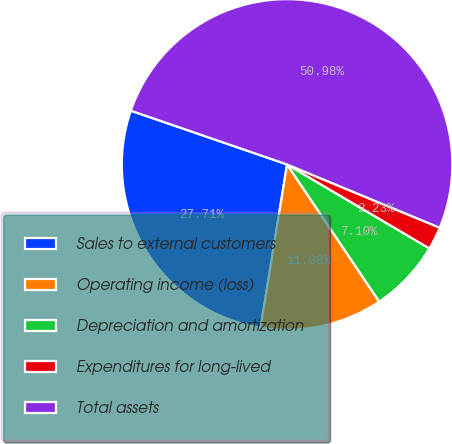Convert chart to OTSL. <chart><loc_0><loc_0><loc_500><loc_500><pie_chart><fcel>Sales to external customers<fcel>Operating income (loss)<fcel>Depreciation and amortization<fcel>Expenditures for long-lived<fcel>Total assets<nl><fcel>27.71%<fcel>11.98%<fcel>7.1%<fcel>2.23%<fcel>50.98%<nl></chart> 